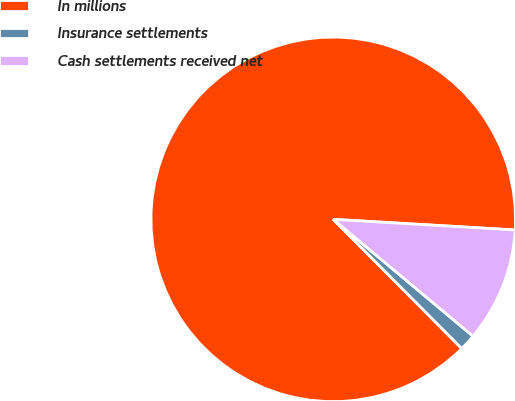Convert chart. <chart><loc_0><loc_0><loc_500><loc_500><pie_chart><fcel>In millions<fcel>Insurance settlements<fcel>Cash settlements received net<nl><fcel>88.39%<fcel>1.46%<fcel>10.15%<nl></chart> 